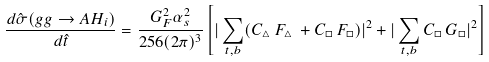Convert formula to latex. <formula><loc_0><loc_0><loc_500><loc_500>\frac { d \hat { \sigma } ( g g \to A H _ { i } ) } { d \hat { t } } = \frac { G _ { F } ^ { 2 } \alpha _ { s } ^ { 2 } } { 2 5 6 ( 2 \pi ) ^ { 3 } } \left [ | \sum _ { t , b } ( C _ { \triangle } \, F _ { \triangle } \, + C _ { \Box } \, F _ { \Box } ) | ^ { 2 } + | \sum _ { t , b } C _ { \Box } \, G _ { \Box } | ^ { 2 } \right ]</formula> 